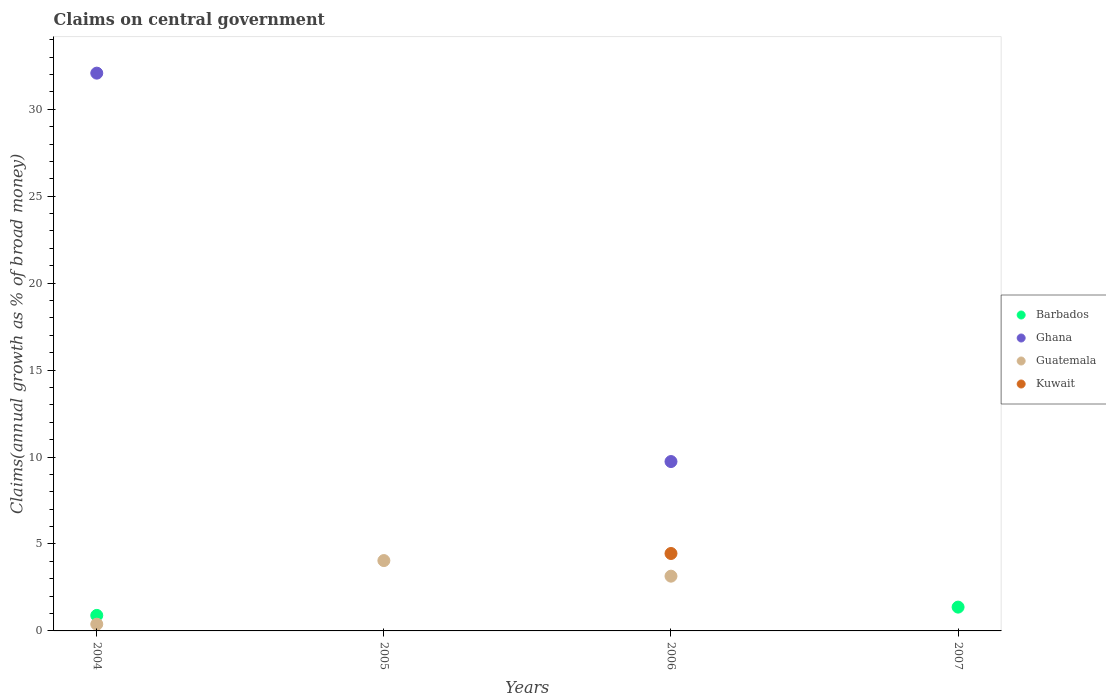What is the percentage of broad money claimed on centeral government in Guatemala in 2004?
Give a very brief answer. 0.39. Across all years, what is the maximum percentage of broad money claimed on centeral government in Ghana?
Your answer should be compact. 32.08. What is the total percentage of broad money claimed on centeral government in Kuwait in the graph?
Your response must be concise. 4.45. What is the difference between the percentage of broad money claimed on centeral government in Guatemala in 2004 and that in 2005?
Provide a short and direct response. -3.66. What is the difference between the percentage of broad money claimed on centeral government in Kuwait in 2004 and the percentage of broad money claimed on centeral government in Guatemala in 2007?
Your answer should be very brief. 0. What is the average percentage of broad money claimed on centeral government in Kuwait per year?
Give a very brief answer. 1.11. In the year 2006, what is the difference between the percentage of broad money claimed on centeral government in Ghana and percentage of broad money claimed on centeral government in Guatemala?
Your response must be concise. 6.59. What is the difference between the highest and the second highest percentage of broad money claimed on centeral government in Guatemala?
Offer a very short reply. 0.9. What is the difference between the highest and the lowest percentage of broad money claimed on centeral government in Barbados?
Your answer should be very brief. 1.37. In how many years, is the percentage of broad money claimed on centeral government in Kuwait greater than the average percentage of broad money claimed on centeral government in Kuwait taken over all years?
Your response must be concise. 1. Is it the case that in every year, the sum of the percentage of broad money claimed on centeral government in Kuwait and percentage of broad money claimed on centeral government in Ghana  is greater than the sum of percentage of broad money claimed on centeral government in Barbados and percentage of broad money claimed on centeral government in Guatemala?
Keep it short and to the point. No. Is it the case that in every year, the sum of the percentage of broad money claimed on centeral government in Kuwait and percentage of broad money claimed on centeral government in Guatemala  is greater than the percentage of broad money claimed on centeral government in Ghana?
Your answer should be compact. No. Is the percentage of broad money claimed on centeral government in Barbados strictly greater than the percentage of broad money claimed on centeral government in Ghana over the years?
Your answer should be very brief. No. How many years are there in the graph?
Your answer should be compact. 4. What is the difference between two consecutive major ticks on the Y-axis?
Ensure brevity in your answer.  5. Are the values on the major ticks of Y-axis written in scientific E-notation?
Give a very brief answer. No. Does the graph contain any zero values?
Provide a short and direct response. Yes. How many legend labels are there?
Your response must be concise. 4. What is the title of the graph?
Offer a terse response. Claims on central government. Does "Ukraine" appear as one of the legend labels in the graph?
Provide a short and direct response. No. What is the label or title of the Y-axis?
Give a very brief answer. Claims(annual growth as % of broad money). What is the Claims(annual growth as % of broad money) of Barbados in 2004?
Give a very brief answer. 0.89. What is the Claims(annual growth as % of broad money) of Ghana in 2004?
Your answer should be compact. 32.08. What is the Claims(annual growth as % of broad money) of Guatemala in 2004?
Provide a short and direct response. 0.39. What is the Claims(annual growth as % of broad money) in Barbados in 2005?
Your response must be concise. 0. What is the Claims(annual growth as % of broad money) in Guatemala in 2005?
Offer a very short reply. 4.05. What is the Claims(annual growth as % of broad money) in Kuwait in 2005?
Ensure brevity in your answer.  0. What is the Claims(annual growth as % of broad money) in Ghana in 2006?
Your answer should be compact. 9.74. What is the Claims(annual growth as % of broad money) in Guatemala in 2006?
Ensure brevity in your answer.  3.15. What is the Claims(annual growth as % of broad money) in Kuwait in 2006?
Your answer should be very brief. 4.45. What is the Claims(annual growth as % of broad money) of Barbados in 2007?
Offer a terse response. 1.37. What is the Claims(annual growth as % of broad money) in Kuwait in 2007?
Offer a very short reply. 0. Across all years, what is the maximum Claims(annual growth as % of broad money) of Barbados?
Offer a terse response. 1.37. Across all years, what is the maximum Claims(annual growth as % of broad money) of Ghana?
Offer a very short reply. 32.08. Across all years, what is the maximum Claims(annual growth as % of broad money) of Guatemala?
Provide a short and direct response. 4.05. Across all years, what is the maximum Claims(annual growth as % of broad money) in Kuwait?
Ensure brevity in your answer.  4.45. Across all years, what is the minimum Claims(annual growth as % of broad money) in Guatemala?
Provide a short and direct response. 0. Across all years, what is the minimum Claims(annual growth as % of broad money) in Kuwait?
Keep it short and to the point. 0. What is the total Claims(annual growth as % of broad money) of Barbados in the graph?
Provide a short and direct response. 2.26. What is the total Claims(annual growth as % of broad money) of Ghana in the graph?
Keep it short and to the point. 41.82. What is the total Claims(annual growth as % of broad money) in Guatemala in the graph?
Offer a very short reply. 7.58. What is the total Claims(annual growth as % of broad money) of Kuwait in the graph?
Your answer should be compact. 4.45. What is the difference between the Claims(annual growth as % of broad money) of Guatemala in 2004 and that in 2005?
Ensure brevity in your answer.  -3.66. What is the difference between the Claims(annual growth as % of broad money) of Ghana in 2004 and that in 2006?
Provide a short and direct response. 22.34. What is the difference between the Claims(annual growth as % of broad money) in Guatemala in 2004 and that in 2006?
Provide a short and direct response. -2.76. What is the difference between the Claims(annual growth as % of broad money) in Barbados in 2004 and that in 2007?
Offer a terse response. -0.48. What is the difference between the Claims(annual growth as % of broad money) in Guatemala in 2005 and that in 2006?
Ensure brevity in your answer.  0.9. What is the difference between the Claims(annual growth as % of broad money) in Barbados in 2004 and the Claims(annual growth as % of broad money) in Guatemala in 2005?
Your answer should be very brief. -3.15. What is the difference between the Claims(annual growth as % of broad money) in Ghana in 2004 and the Claims(annual growth as % of broad money) in Guatemala in 2005?
Your answer should be very brief. 28.03. What is the difference between the Claims(annual growth as % of broad money) of Barbados in 2004 and the Claims(annual growth as % of broad money) of Ghana in 2006?
Your response must be concise. -8.85. What is the difference between the Claims(annual growth as % of broad money) in Barbados in 2004 and the Claims(annual growth as % of broad money) in Guatemala in 2006?
Give a very brief answer. -2.26. What is the difference between the Claims(annual growth as % of broad money) in Barbados in 2004 and the Claims(annual growth as % of broad money) in Kuwait in 2006?
Give a very brief answer. -3.56. What is the difference between the Claims(annual growth as % of broad money) of Ghana in 2004 and the Claims(annual growth as % of broad money) of Guatemala in 2006?
Provide a short and direct response. 28.93. What is the difference between the Claims(annual growth as % of broad money) of Ghana in 2004 and the Claims(annual growth as % of broad money) of Kuwait in 2006?
Your answer should be compact. 27.62. What is the difference between the Claims(annual growth as % of broad money) of Guatemala in 2004 and the Claims(annual growth as % of broad money) of Kuwait in 2006?
Your answer should be compact. -4.06. What is the difference between the Claims(annual growth as % of broad money) of Guatemala in 2005 and the Claims(annual growth as % of broad money) of Kuwait in 2006?
Your response must be concise. -0.41. What is the average Claims(annual growth as % of broad money) of Barbados per year?
Provide a succinct answer. 0.57. What is the average Claims(annual growth as % of broad money) in Ghana per year?
Offer a terse response. 10.45. What is the average Claims(annual growth as % of broad money) of Guatemala per year?
Offer a very short reply. 1.9. What is the average Claims(annual growth as % of broad money) in Kuwait per year?
Your answer should be very brief. 1.11. In the year 2004, what is the difference between the Claims(annual growth as % of broad money) in Barbados and Claims(annual growth as % of broad money) in Ghana?
Ensure brevity in your answer.  -31.18. In the year 2004, what is the difference between the Claims(annual growth as % of broad money) of Barbados and Claims(annual growth as % of broad money) of Guatemala?
Keep it short and to the point. 0.5. In the year 2004, what is the difference between the Claims(annual growth as % of broad money) in Ghana and Claims(annual growth as % of broad money) in Guatemala?
Offer a very short reply. 31.69. In the year 2006, what is the difference between the Claims(annual growth as % of broad money) of Ghana and Claims(annual growth as % of broad money) of Guatemala?
Your answer should be compact. 6.59. In the year 2006, what is the difference between the Claims(annual growth as % of broad money) in Ghana and Claims(annual growth as % of broad money) in Kuwait?
Your answer should be very brief. 5.29. In the year 2006, what is the difference between the Claims(annual growth as % of broad money) of Guatemala and Claims(annual growth as % of broad money) of Kuwait?
Offer a very short reply. -1.3. What is the ratio of the Claims(annual growth as % of broad money) in Guatemala in 2004 to that in 2005?
Provide a succinct answer. 0.1. What is the ratio of the Claims(annual growth as % of broad money) in Ghana in 2004 to that in 2006?
Offer a very short reply. 3.29. What is the ratio of the Claims(annual growth as % of broad money) in Guatemala in 2004 to that in 2006?
Keep it short and to the point. 0.12. What is the ratio of the Claims(annual growth as % of broad money) of Barbados in 2004 to that in 2007?
Make the answer very short. 0.65. What is the ratio of the Claims(annual growth as % of broad money) in Guatemala in 2005 to that in 2006?
Provide a succinct answer. 1.28. What is the difference between the highest and the second highest Claims(annual growth as % of broad money) of Guatemala?
Give a very brief answer. 0.9. What is the difference between the highest and the lowest Claims(annual growth as % of broad money) in Barbados?
Ensure brevity in your answer.  1.37. What is the difference between the highest and the lowest Claims(annual growth as % of broad money) of Ghana?
Your response must be concise. 32.08. What is the difference between the highest and the lowest Claims(annual growth as % of broad money) of Guatemala?
Your answer should be very brief. 4.05. What is the difference between the highest and the lowest Claims(annual growth as % of broad money) of Kuwait?
Provide a succinct answer. 4.45. 